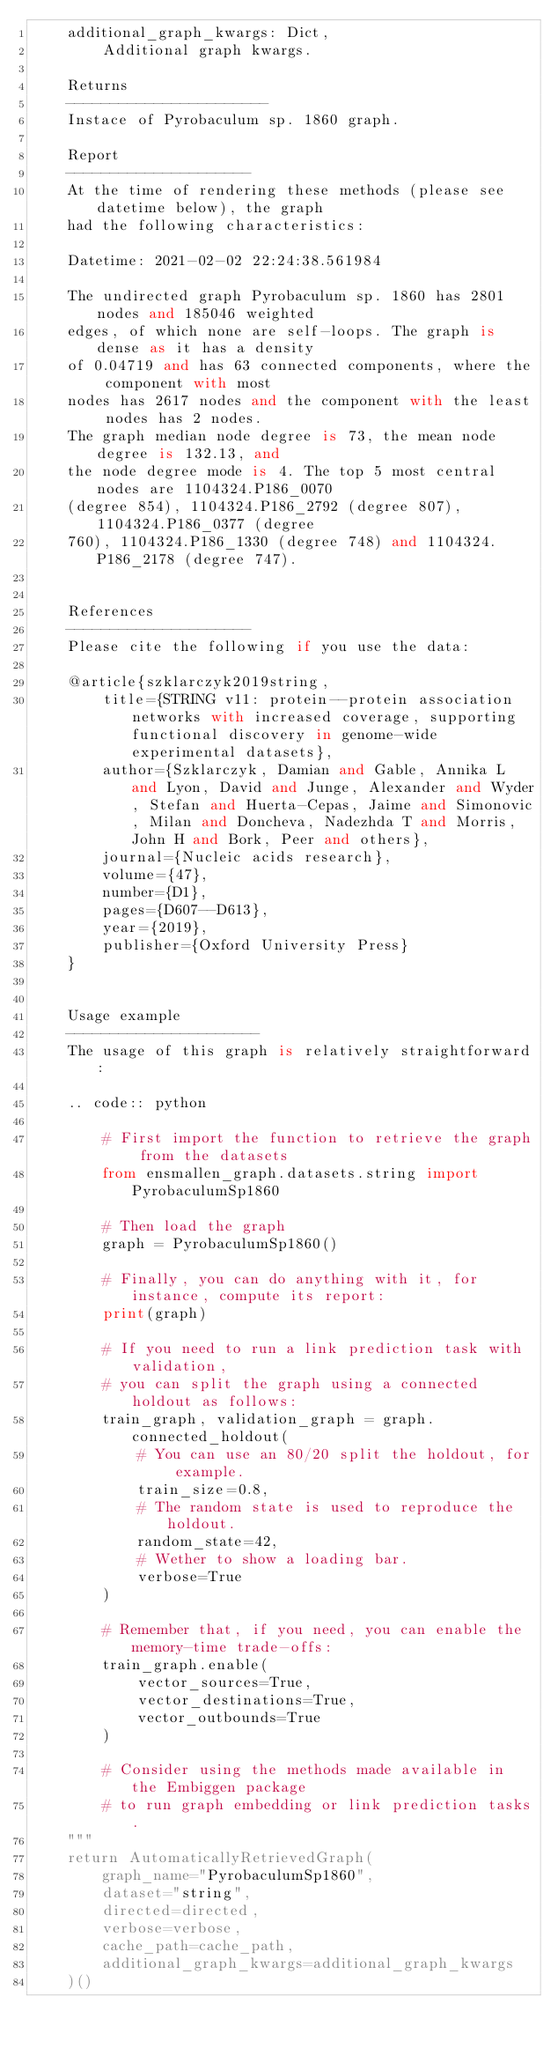Convert code to text. <code><loc_0><loc_0><loc_500><loc_500><_Python_>    additional_graph_kwargs: Dict,
        Additional graph kwargs.

    Returns
    -----------------------
    Instace of Pyrobaculum sp. 1860 graph.

	Report
	---------------------
	At the time of rendering these methods (please see datetime below), the graph
	had the following characteristics:
	
	Datetime: 2021-02-02 22:24:38.561984
	
	The undirected graph Pyrobaculum sp. 1860 has 2801 nodes and 185046 weighted
	edges, of which none are self-loops. The graph is dense as it has a density
	of 0.04719 and has 63 connected components, where the component with most
	nodes has 2617 nodes and the component with the least nodes has 2 nodes.
	The graph median node degree is 73, the mean node degree is 132.13, and
	the node degree mode is 4. The top 5 most central nodes are 1104324.P186_0070
	(degree 854), 1104324.P186_2792 (degree 807), 1104324.P186_0377 (degree
	760), 1104324.P186_1330 (degree 748) and 1104324.P186_2178 (degree 747).
	

	References
	---------------------
	Please cite the following if you use the data:
	
	@article{szklarczyk2019string,
	    title={STRING v11: protein--protein association networks with increased coverage, supporting functional discovery in genome-wide experimental datasets},
	    author={Szklarczyk, Damian and Gable, Annika L and Lyon, David and Junge, Alexander and Wyder, Stefan and Huerta-Cepas, Jaime and Simonovic, Milan and Doncheva, Nadezhda T and Morris, John H and Bork, Peer and others},
	    journal={Nucleic acids research},
	    volume={47},
	    number={D1},
	    pages={D607--D613},
	    year={2019},
	    publisher={Oxford University Press}
	}
	

	Usage example
	----------------------
	The usage of this graph is relatively straightforward:
	
	.. code:: python
	
	    # First import the function to retrieve the graph from the datasets
	    from ensmallen_graph.datasets.string import PyrobaculumSp1860
	
	    # Then load the graph
	    graph = PyrobaculumSp1860()
	
	    # Finally, you can do anything with it, for instance, compute its report:
	    print(graph)
	
	    # If you need to run a link prediction task with validation,
	    # you can split the graph using a connected holdout as follows:
	    train_graph, validation_graph = graph.connected_holdout(
	        # You can use an 80/20 split the holdout, for example.
	        train_size=0.8,
	        # The random state is used to reproduce the holdout.
	        random_state=42,
	        # Wether to show a loading bar.
	        verbose=True
	    )
	
	    # Remember that, if you need, you can enable the memory-time trade-offs:
	    train_graph.enable(
	        vector_sources=True,
	        vector_destinations=True,
	        vector_outbounds=True
	    )
	
	    # Consider using the methods made available in the Embiggen package
	    # to run graph embedding or link prediction tasks.
    """
    return AutomaticallyRetrievedGraph(
        graph_name="PyrobaculumSp1860",
        dataset="string",
        directed=directed,
        verbose=verbose,
        cache_path=cache_path,
        additional_graph_kwargs=additional_graph_kwargs
    )()
</code> 